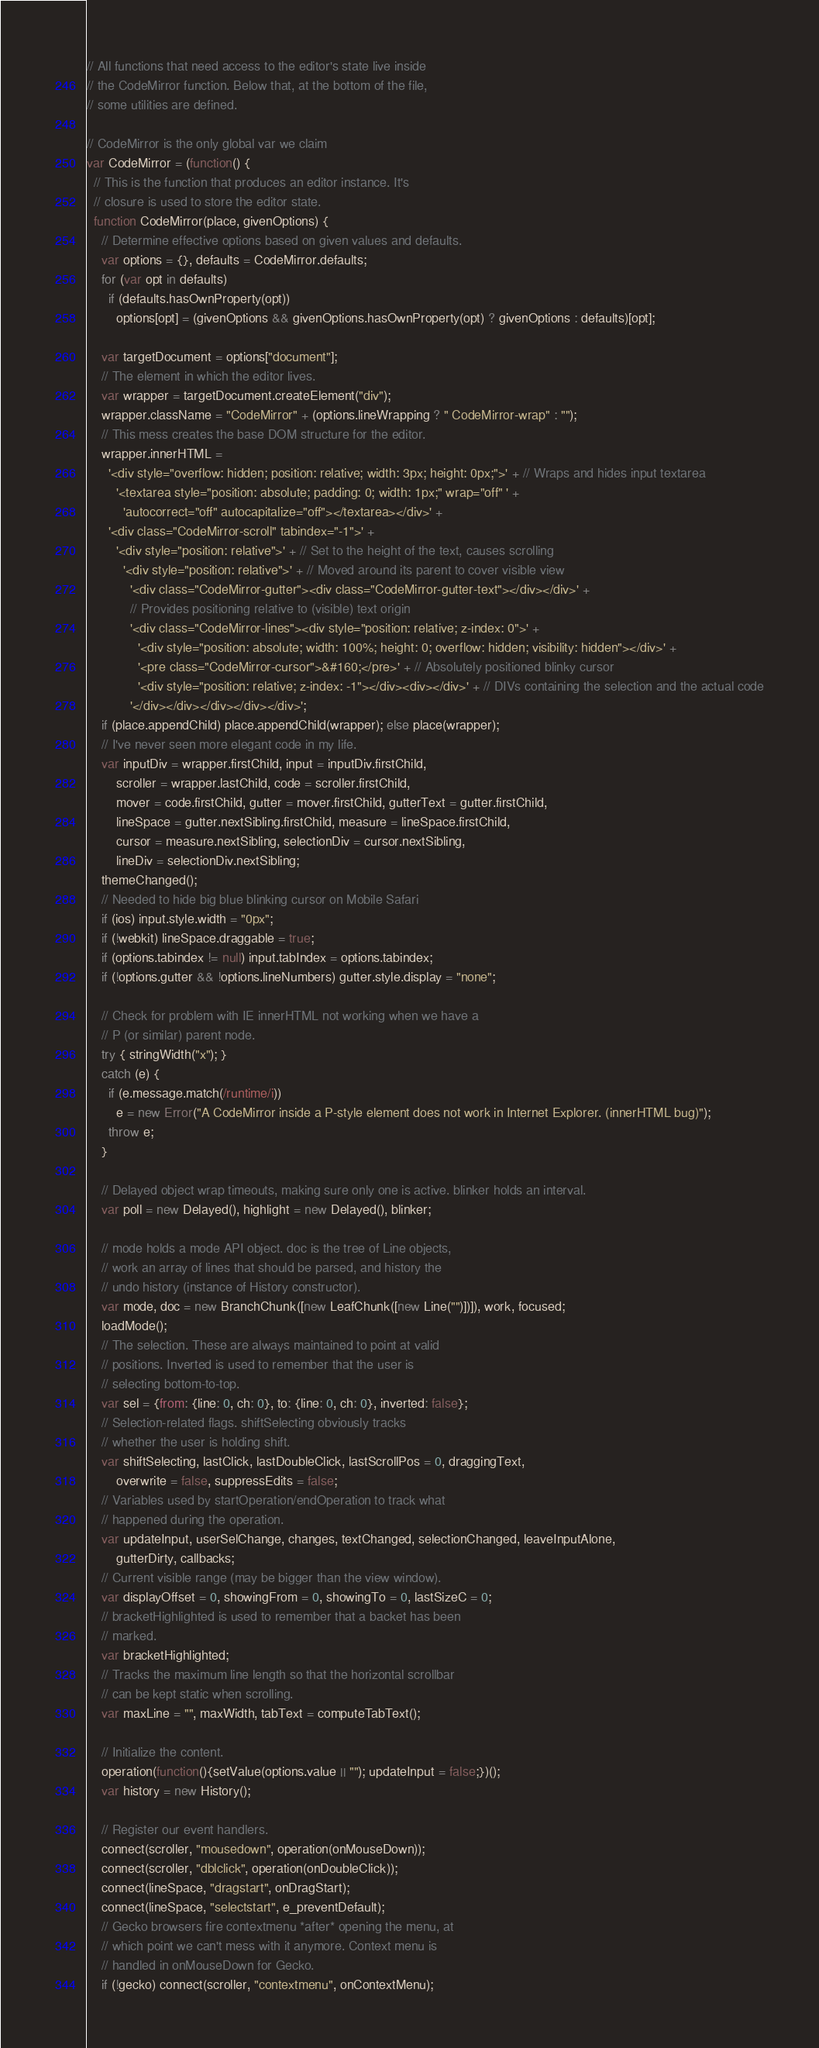Convert code to text. <code><loc_0><loc_0><loc_500><loc_500><_JavaScript_>// All functions that need access to the editor's state live inside
// the CodeMirror function. Below that, at the bottom of the file,
// some utilities are defined.

// CodeMirror is the only global var we claim
var CodeMirror = (function() {
  // This is the function that produces an editor instance. It's
  // closure is used to store the editor state.
  function CodeMirror(place, givenOptions) {
    // Determine effective options based on given values and defaults.
    var options = {}, defaults = CodeMirror.defaults;
    for (var opt in defaults)
      if (defaults.hasOwnProperty(opt))
        options[opt] = (givenOptions && givenOptions.hasOwnProperty(opt) ? givenOptions : defaults)[opt];

    var targetDocument = options["document"];
    // The element in which the editor lives.
    var wrapper = targetDocument.createElement("div");
    wrapper.className = "CodeMirror" + (options.lineWrapping ? " CodeMirror-wrap" : "");
    // This mess creates the base DOM structure for the editor.
    wrapper.innerHTML =
      '<div style="overflow: hidden; position: relative; width: 3px; height: 0px;">' + // Wraps and hides input textarea
        '<textarea style="position: absolute; padding: 0; width: 1px;" wrap="off" ' +
          'autocorrect="off" autocapitalize="off"></textarea></div>' +
      '<div class="CodeMirror-scroll" tabindex="-1">' +
        '<div style="position: relative">' + // Set to the height of the text, causes scrolling
          '<div style="position: relative">' + // Moved around its parent to cover visible view
            '<div class="CodeMirror-gutter"><div class="CodeMirror-gutter-text"></div></div>' +
            // Provides positioning relative to (visible) text origin
            '<div class="CodeMirror-lines"><div style="position: relative; z-index: 0">' +
              '<div style="position: absolute; width: 100%; height: 0; overflow: hidden; visibility: hidden"></div>' +
              '<pre class="CodeMirror-cursor">&#160;</pre>' + // Absolutely positioned blinky cursor
              '<div style="position: relative; z-index: -1"></div><div></div>' + // DIVs containing the selection and the actual code
            '</div></div></div></div></div>';
    if (place.appendChild) place.appendChild(wrapper); else place(wrapper);
    // I've never seen more elegant code in my life.
    var inputDiv = wrapper.firstChild, input = inputDiv.firstChild,
        scroller = wrapper.lastChild, code = scroller.firstChild,
        mover = code.firstChild, gutter = mover.firstChild, gutterText = gutter.firstChild,
        lineSpace = gutter.nextSibling.firstChild, measure = lineSpace.firstChild,
        cursor = measure.nextSibling, selectionDiv = cursor.nextSibling,
        lineDiv = selectionDiv.nextSibling;
    themeChanged();
    // Needed to hide big blue blinking cursor on Mobile Safari
    if (ios) input.style.width = "0px";
    if (!webkit) lineSpace.draggable = true;
    if (options.tabindex != null) input.tabIndex = options.tabindex;
    if (!options.gutter && !options.lineNumbers) gutter.style.display = "none";

    // Check for problem with IE innerHTML not working when we have a
    // P (or similar) parent node.
    try { stringWidth("x"); }
    catch (e) {
      if (e.message.match(/runtime/i))
        e = new Error("A CodeMirror inside a P-style element does not work in Internet Explorer. (innerHTML bug)");
      throw e;
    }

    // Delayed object wrap timeouts, making sure only one is active. blinker holds an interval.
    var poll = new Delayed(), highlight = new Delayed(), blinker;

    // mode holds a mode API object. doc is the tree of Line objects,
    // work an array of lines that should be parsed, and history the
    // undo history (instance of History constructor).
    var mode, doc = new BranchChunk([new LeafChunk([new Line("")])]), work, focused;
    loadMode();
    // The selection. These are always maintained to point at valid
    // positions. Inverted is used to remember that the user is
    // selecting bottom-to-top.
    var sel = {from: {line: 0, ch: 0}, to: {line: 0, ch: 0}, inverted: false};
    // Selection-related flags. shiftSelecting obviously tracks
    // whether the user is holding shift.
    var shiftSelecting, lastClick, lastDoubleClick, lastScrollPos = 0, draggingText,
        overwrite = false, suppressEdits = false;
    // Variables used by startOperation/endOperation to track what
    // happened during the operation.
    var updateInput, userSelChange, changes, textChanged, selectionChanged, leaveInputAlone,
        gutterDirty, callbacks;
    // Current visible range (may be bigger than the view window).
    var displayOffset = 0, showingFrom = 0, showingTo = 0, lastSizeC = 0;
    // bracketHighlighted is used to remember that a backet has been
    // marked.
    var bracketHighlighted;
    // Tracks the maximum line length so that the horizontal scrollbar
    // can be kept static when scrolling.
    var maxLine = "", maxWidth, tabText = computeTabText();

    // Initialize the content.
    operation(function(){setValue(options.value || ""); updateInput = false;})();
    var history = new History();

    // Register our event handlers.
    connect(scroller, "mousedown", operation(onMouseDown));
    connect(scroller, "dblclick", operation(onDoubleClick));
    connect(lineSpace, "dragstart", onDragStart);
    connect(lineSpace, "selectstart", e_preventDefault);
    // Gecko browsers fire contextmenu *after* opening the menu, at
    // which point we can't mess with it anymore. Context menu is
    // handled in onMouseDown for Gecko.
    if (!gecko) connect(scroller, "contextmenu", onContextMenu);</code> 